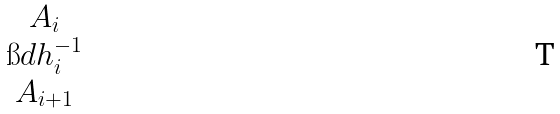<formula> <loc_0><loc_0><loc_500><loc_500>\begin{matrix} A _ { i } \\ \i d h _ { i } ^ { - 1 } \\ A _ { i + 1 } \end{matrix}</formula> 